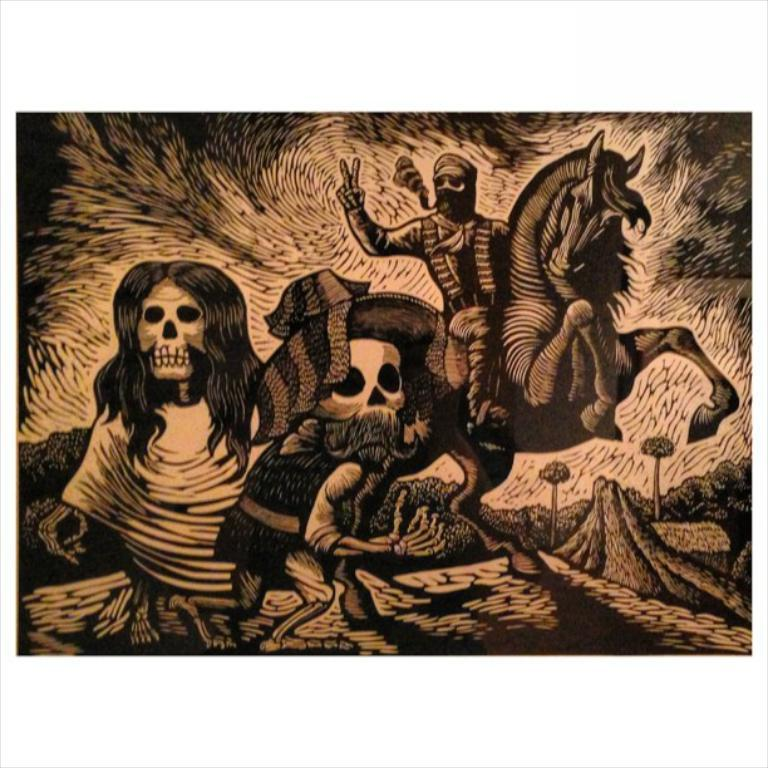What type of drawing is featured in the image? The image contains a drawing of monsters and a person on a horse. What can be seen in the background of the drawing? There are trees in the background of the image. What type of game is being played in the image? There is no game being played in the image; it is a drawing of monsters and a person on a horse. What kind of creature is depicted in the image? The image contains a drawing of monsters, but it does not depict any specific creature. 